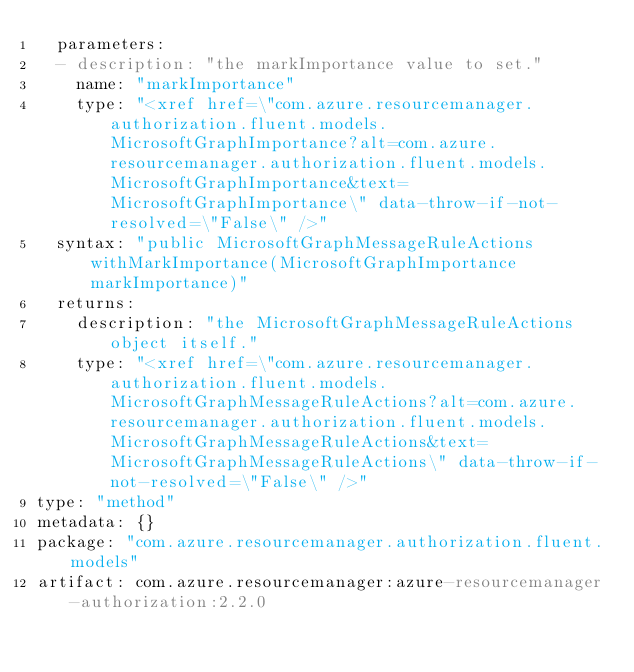<code> <loc_0><loc_0><loc_500><loc_500><_YAML_>  parameters:
  - description: "the markImportance value to set."
    name: "markImportance"
    type: "<xref href=\"com.azure.resourcemanager.authorization.fluent.models.MicrosoftGraphImportance?alt=com.azure.resourcemanager.authorization.fluent.models.MicrosoftGraphImportance&text=MicrosoftGraphImportance\" data-throw-if-not-resolved=\"False\" />"
  syntax: "public MicrosoftGraphMessageRuleActions withMarkImportance(MicrosoftGraphImportance markImportance)"
  returns:
    description: "the MicrosoftGraphMessageRuleActions object itself."
    type: "<xref href=\"com.azure.resourcemanager.authorization.fluent.models.MicrosoftGraphMessageRuleActions?alt=com.azure.resourcemanager.authorization.fluent.models.MicrosoftGraphMessageRuleActions&text=MicrosoftGraphMessageRuleActions\" data-throw-if-not-resolved=\"False\" />"
type: "method"
metadata: {}
package: "com.azure.resourcemanager.authorization.fluent.models"
artifact: com.azure.resourcemanager:azure-resourcemanager-authorization:2.2.0
</code> 